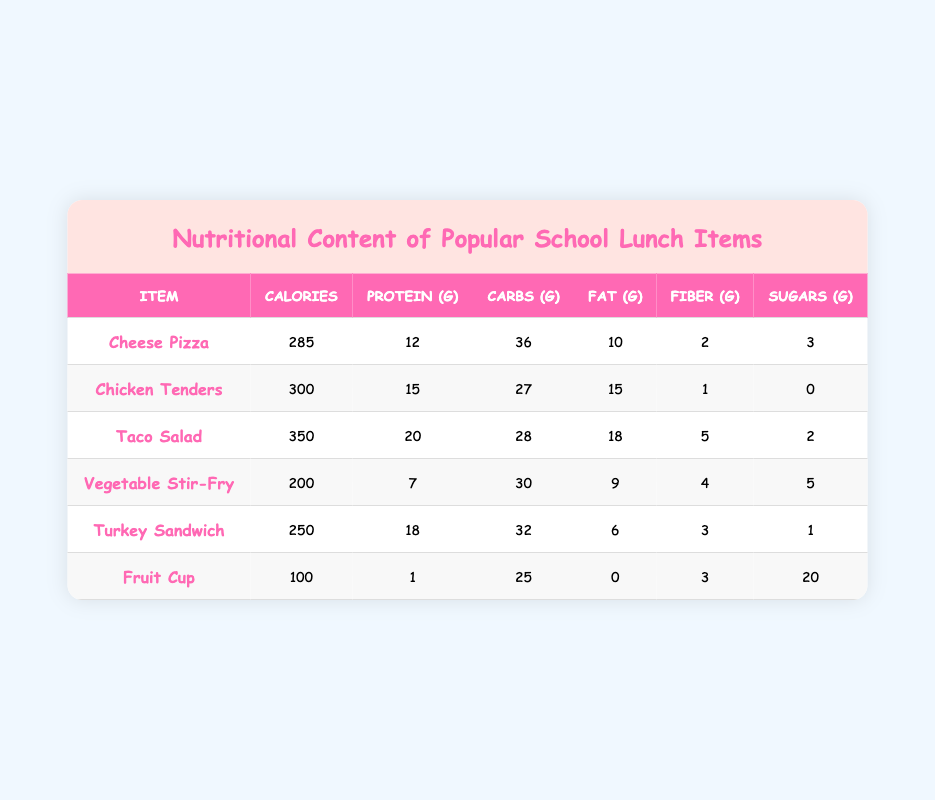What is the calorie content of Taco Salad? The table lists the calorie content for Taco Salad, which is specifically mentioned in the table.
Answer: 350 Which school lunch item has the highest protein content? By looking through the protein column, Taco Salad shows the highest value of 20 grams.
Answer: Taco Salad What is the total amount of carbohydrates in Cheese Pizza and Turkey Sandwich? Adding the carbohydrates from both items: Cheese Pizza has 36 grams and Turkey Sandwich has 32 grams, therefore the total is 36 + 32 = 68 grams.
Answer: 68 grams Is Vegetable Stir-Fry lower in calories than Fruit Cup? Comparing the calories, Vegetable Stir-Fry has 200 calories while Fruit Cup has 100 calories, which means Vegetable Stir-Fry has more calories.
Answer: No Which item has the least amount of fat? The table indicates that the Fruit Cup has 0 grams of fat, which is the lowest value among all items.
Answer: Fruit Cup What is the average fiber content of Chicken Tenders and Taco Salad? Chicken Tenders has 1 gram of fiber and Taco Salad has 5 grams. To find the average, sum these values (1 + 5 = 6) and divide by 2; thus the average is 6/2 = 3 grams.
Answer: 3 grams How many items have more than 250 calories? Checking the calorie values: Cheese Pizza (285), Chicken Tenders (300), Taco Salad (350), and Vegetable Stir-Fry (200), only 3 items exceed 250 calories: Cheese Pizza, Chicken Tenders, and Taco Salad.
Answer: 3 items Is the sugar content of the Fruit Cup greater than that of the Taco Salad? The Fruit Cup has 20 grams of sugar while the Taco Salad has only 2 grams, clearly showing that the Fruit Cup has a higher sugar content.
Answer: Yes What is the total protein content for all lunch items combined? Adding the protein from each item gives: 12 + 15 + 20 + 7 + 18 + 1 = 73 grams of protein in total across all items.
Answer: 73 grams 